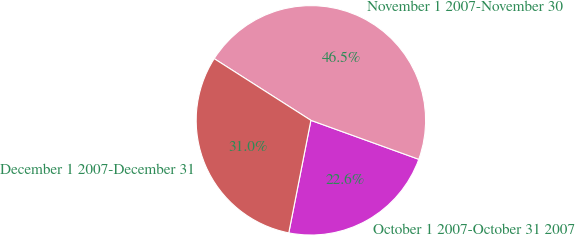<chart> <loc_0><loc_0><loc_500><loc_500><pie_chart><fcel>October 1 2007-October 31 2007<fcel>November 1 2007-November 30<fcel>December 1 2007-December 31<nl><fcel>22.57%<fcel>46.48%<fcel>30.95%<nl></chart> 